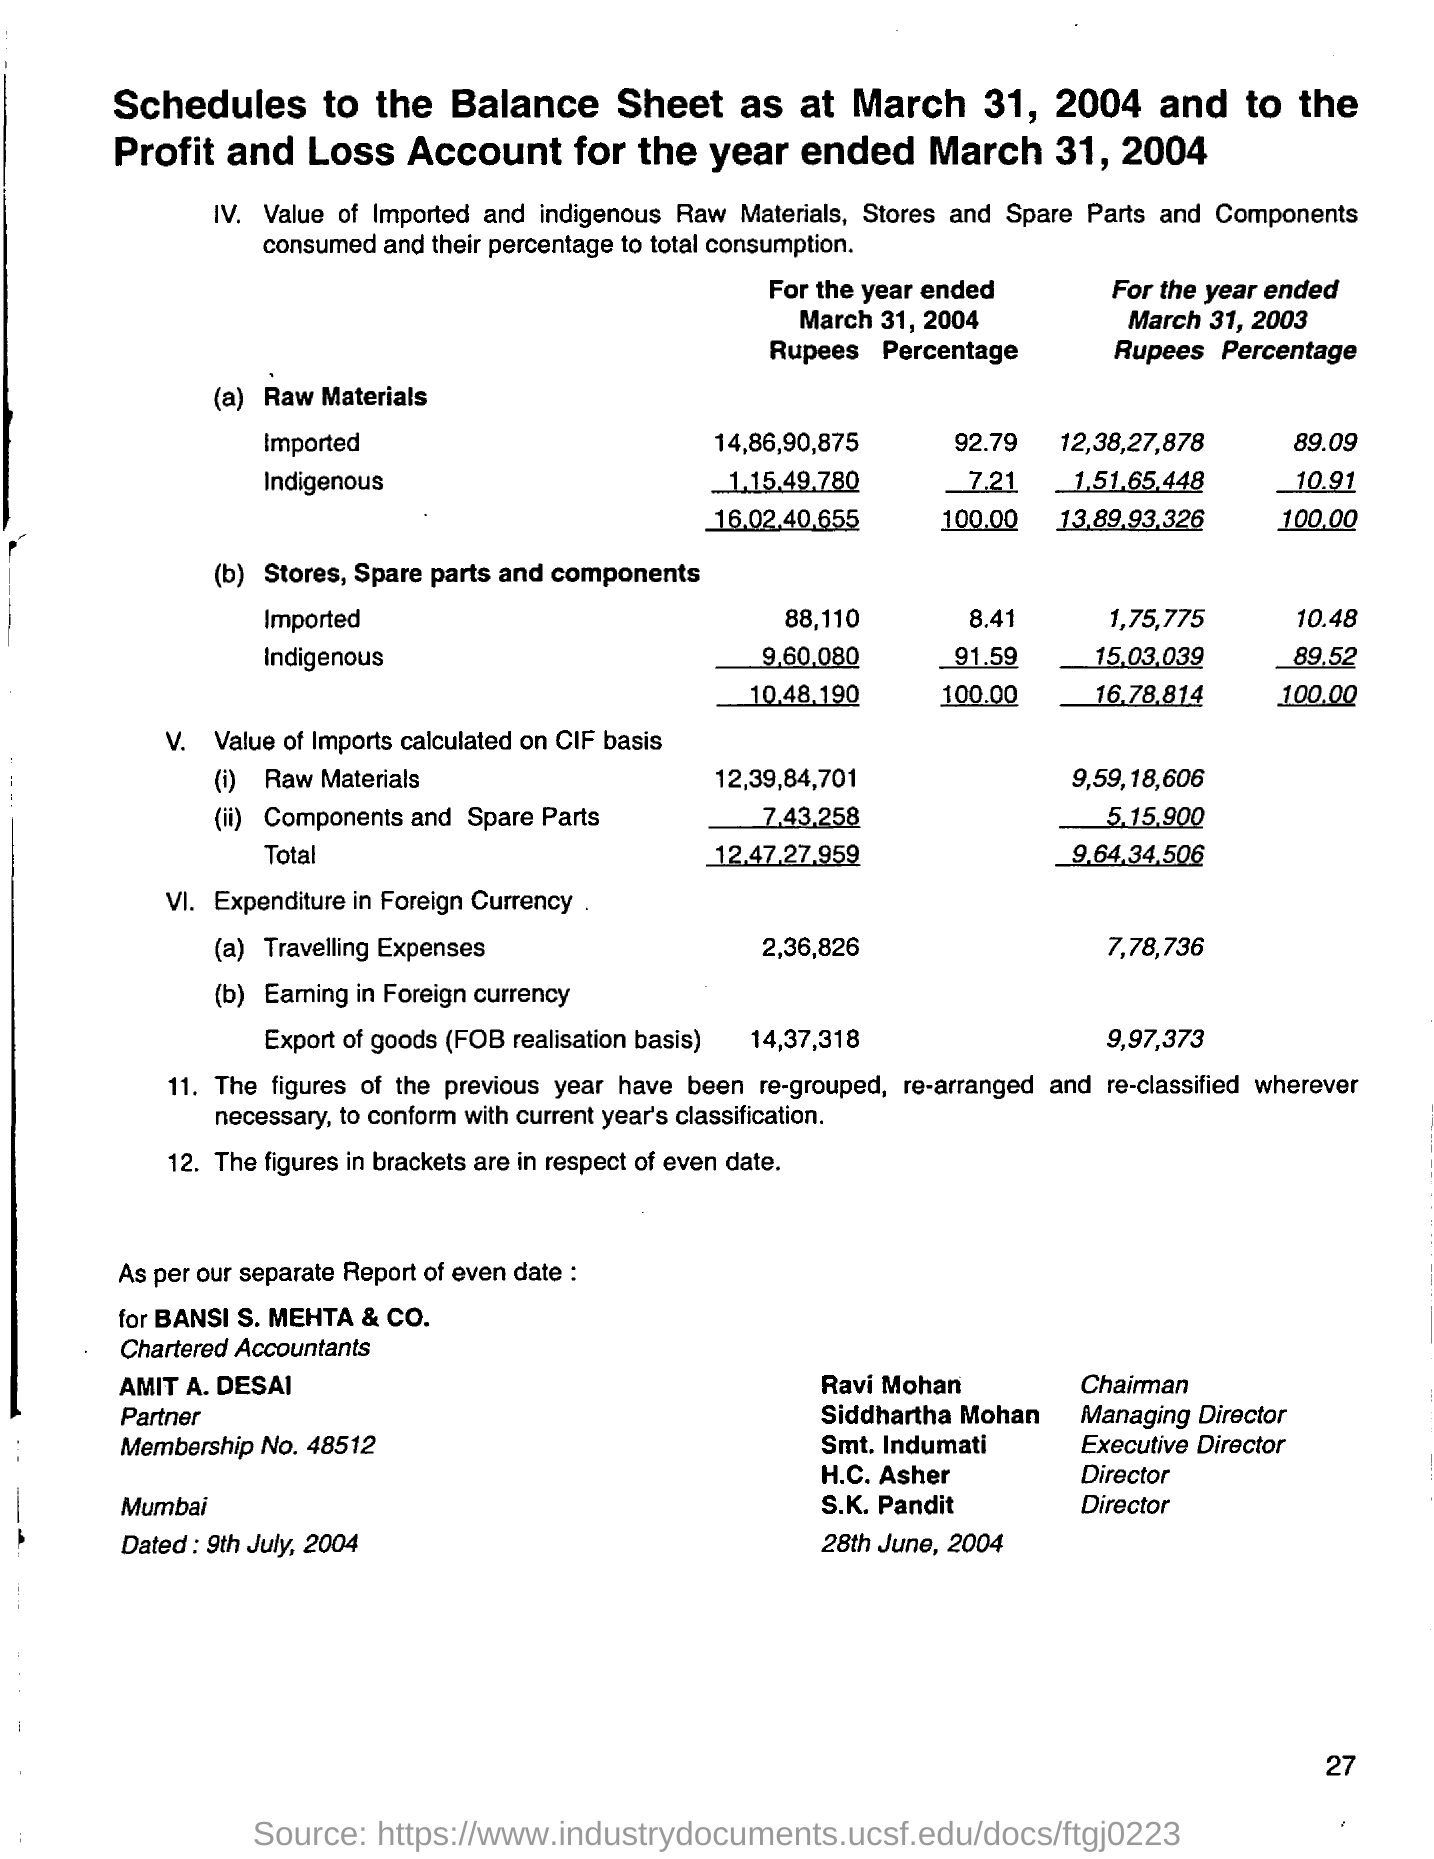What is the percentage of raw materials imported for the year ended march 31, 2004?
Keep it short and to the point. 92.79. How much is the cost of indegeneous raw materials for the year ended march 31, 2004?
Your response must be concise. 1,15,49,780. What is the total value of imports calculated on cif basis for the year ended march 31, 2004?
Provide a short and direct response. 12,47,27,959. How much is the travelling expenses for the year ended march 31, 2003?
Ensure brevity in your answer.  7,78,736. Who is the partner of bansi s. mehta & co.?
Make the answer very short. Amit A. Desai. What is the designation of ravi maohan?
Keep it short and to the point. Chairman. 